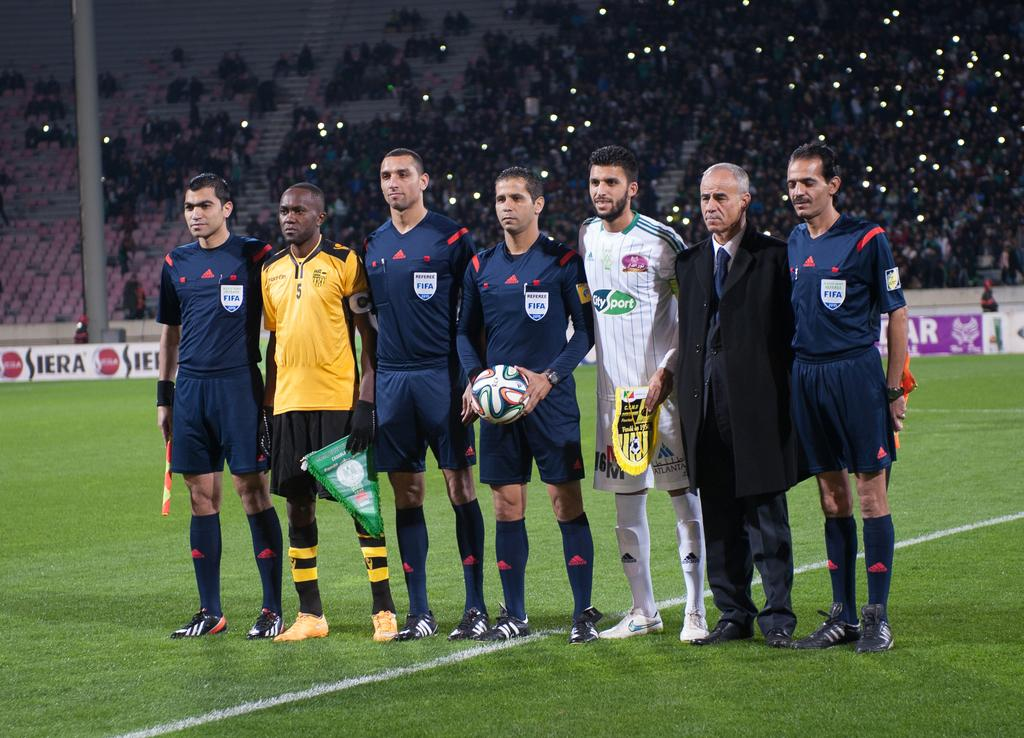What are the people in the image doing? There are people standing in the image. Can you describe what the man is holding? The man is holding a ball in the image. What are some people holding in addition to the man with the ball? Some people are holding flags in the image. What can be seen in the background of the image? There is a stadium visible in the background of the image. What type of zephyr can be seen blowing through the stadium in the image? There is no mention of a zephyr or any wind in the image; it simply shows people standing, a man holding a ball, and some people holding flags. 